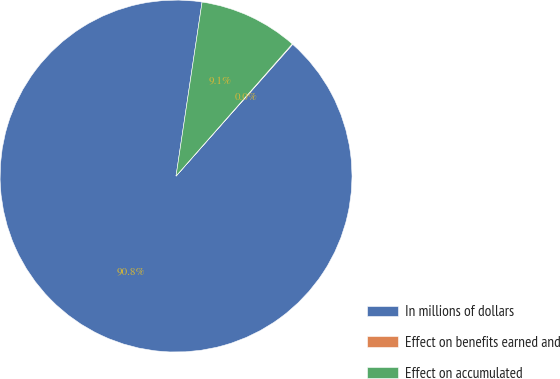Convert chart to OTSL. <chart><loc_0><loc_0><loc_500><loc_500><pie_chart><fcel>In millions of dollars<fcel>Effect on benefits earned and<fcel>Effect on accumulated<nl><fcel>90.83%<fcel>0.05%<fcel>9.12%<nl></chart> 